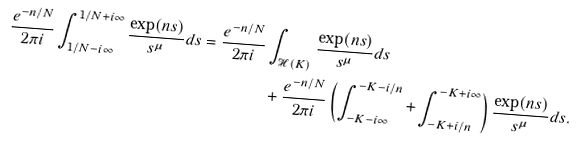Convert formula to latex. <formula><loc_0><loc_0><loc_500><loc_500>\frac { e ^ { - n / N } } { 2 \pi i } \int _ { 1 / N - i \infty } ^ { 1 / N + i \infty } \frac { \exp ( n s ) } { s ^ { \mu } } d s = \frac { e ^ { - n / N } } { 2 \pi i } & \int _ { \mathcal { H } ( K ) } \frac { \exp ( n s ) } { s ^ { \mu } } d s \\ & + \frac { e ^ { - n / N } } { 2 \pi i } \left ( \int _ { - K - i \infty } ^ { - K - i / n } + \int _ { - K + i / n } ^ { - K + i \infty } \right ) \frac { \exp ( n s ) } { s ^ { \mu } } d s .</formula> 